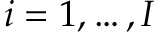Convert formula to latex. <formula><loc_0><loc_0><loc_500><loc_500>i = 1 , \dots , I</formula> 